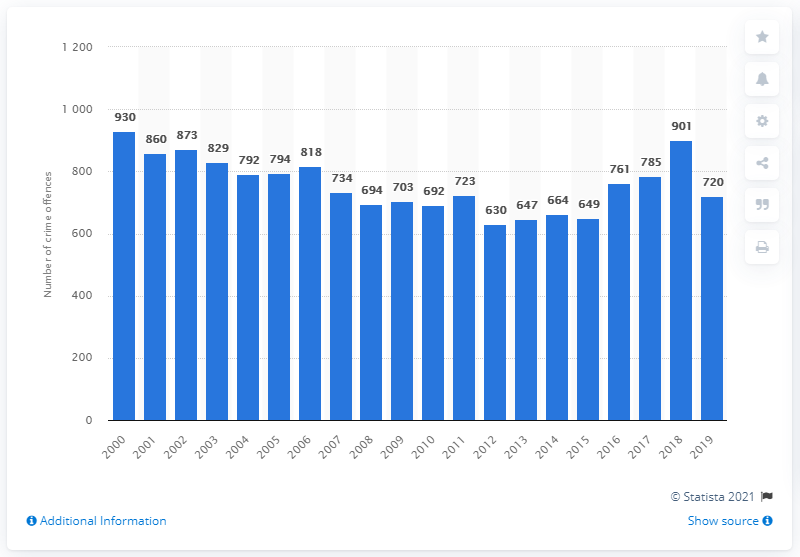Outline some significant characteristics in this image. In 2019, there were 720 murders in Germany. In 2000, a total of 930 murders were committed in Germany. 